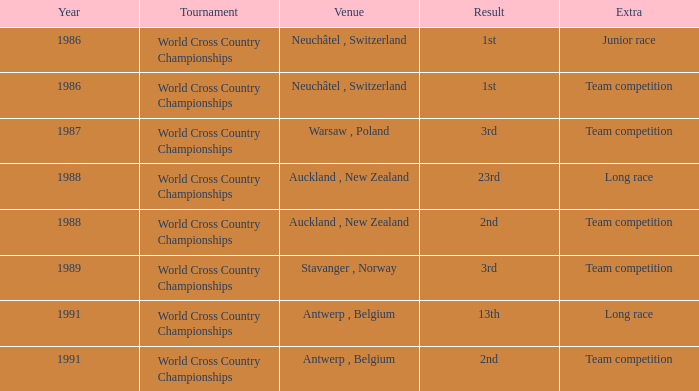Which venue led to a result of 13th and had an extra of Long Race? Antwerp , Belgium. 